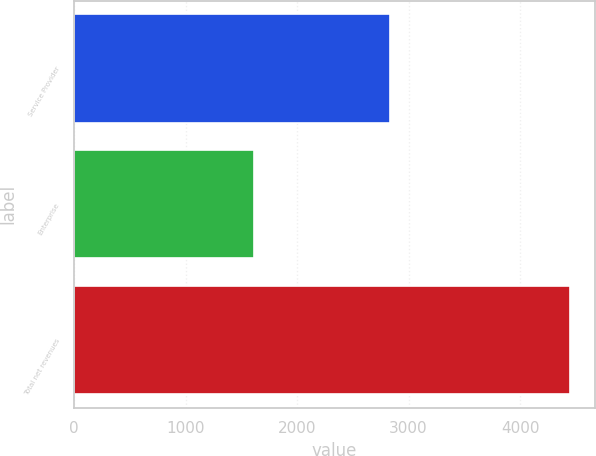Convert chart. <chart><loc_0><loc_0><loc_500><loc_500><bar_chart><fcel>Service Provider<fcel>Enterprise<fcel>Total net revenues<nl><fcel>2833<fcel>1615.7<fcel>4448.7<nl></chart> 